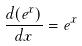<formula> <loc_0><loc_0><loc_500><loc_500>\frac { d ( e ^ { x } ) } { d x } = e ^ { x }</formula> 